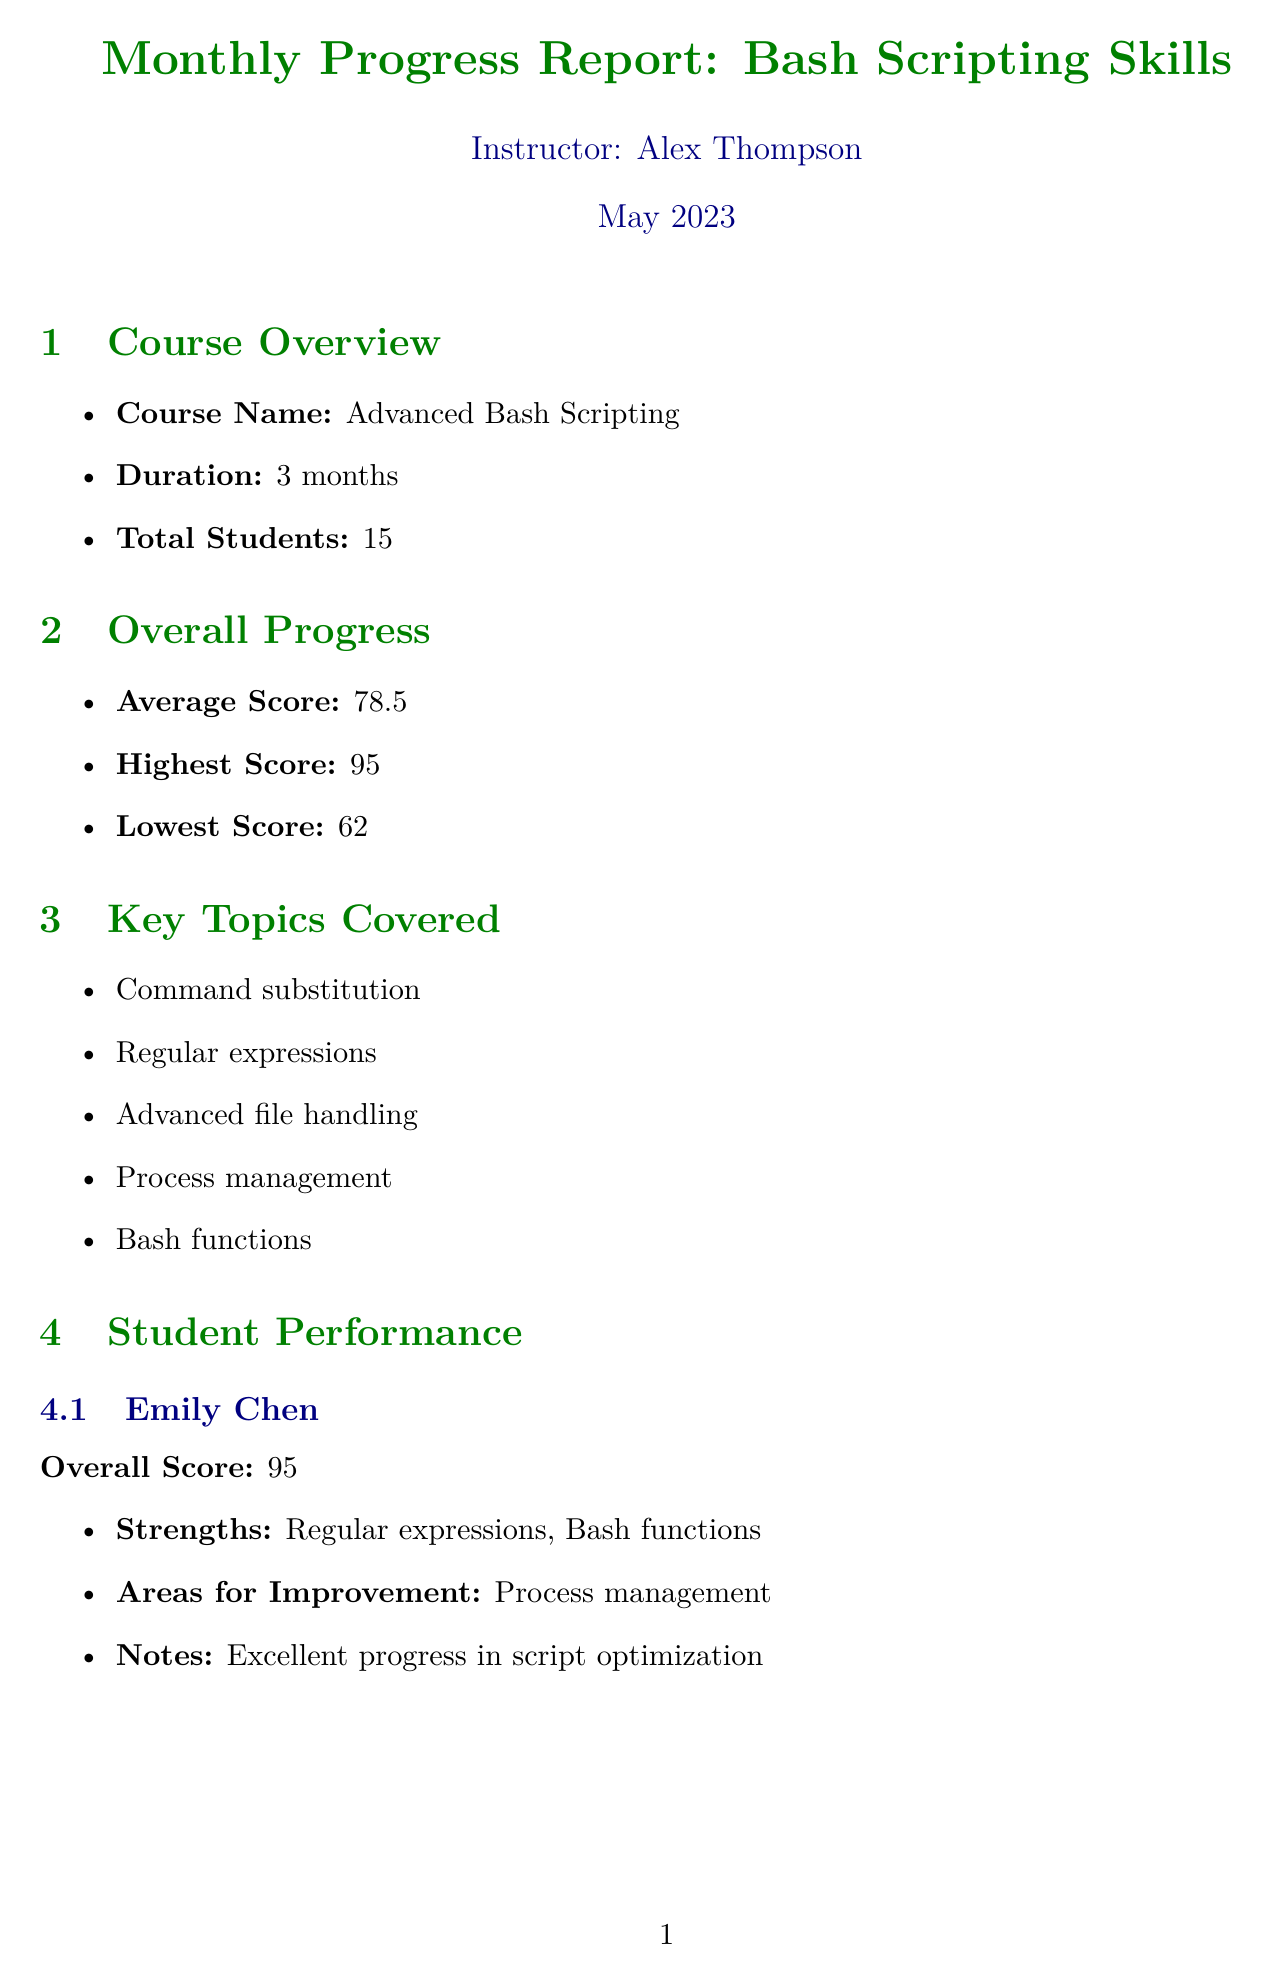What is the instructor's name? The instructor of the course is mentioned in the document, which is Alex Thompson.
Answer: Alex Thompson What is the average score of the students? The average score is calculated from the overall performance of the students, which is noted as 78.5.
Answer: 78.5 Who scored the highest in the class? The highest score recorded in the document is for Emily Chen, who achieved a noted score of 95.
Answer: Emily Chen What area does Marcus Johnson need improvement in? According to the performance metrics, Marcus Johnson needs improvement in Regular expressions.
Answer: Regular expressions What is the total number of students enrolled? The document states the total number of students participating in the course as 15.
Answer: 15 What percentage of students participated in peer code review sessions? The average participation in peer code review sessions is provided in the report, which is 92 percent.
Answer: 92% Which topic is going to be focused on next? The upcoming focus includes several topics, one of which is Advanced text processing with awk and sed.
Answer: Advanced text processing with awk and sed What is the lowest score achieved by a student? The document notes the lowest score that was achieved, which is 62.
Answer: 62 What recommendation is made for students struggling with regular expressions? One of the recommendations is to organize small group sessions for students who struggle with regular expressions.
Answer: Organize small group sessions for students struggling with regular expressions 